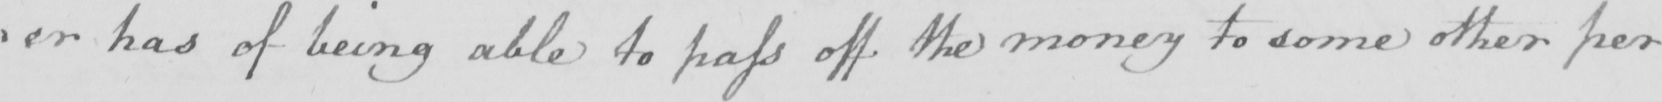Can you read and transcribe this handwriting? : or has of being able to pass off the money to some other per 